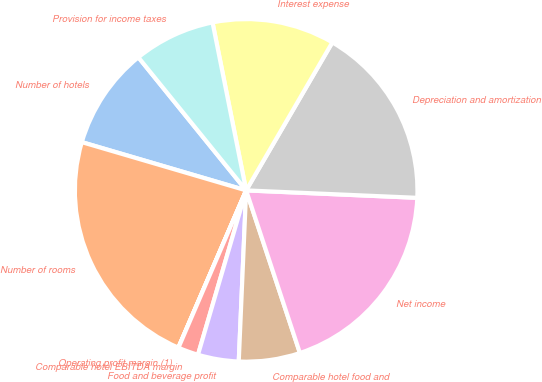<chart> <loc_0><loc_0><loc_500><loc_500><pie_chart><fcel>Number of hotels<fcel>Number of rooms<fcel>Operating profit margin (1)<fcel>Comparable hotel EBITDA margin<fcel>Food and beverage profit<fcel>Comparable hotel food and<fcel>Net income<fcel>Depreciation and amortization<fcel>Interest expense<fcel>Provision for income taxes<nl><fcel>9.62%<fcel>23.07%<fcel>0.01%<fcel>1.93%<fcel>3.85%<fcel>5.77%<fcel>19.23%<fcel>17.3%<fcel>11.54%<fcel>7.69%<nl></chart> 